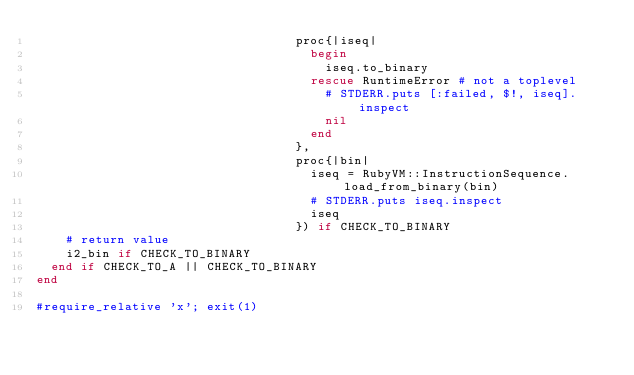<code> <loc_0><loc_0><loc_500><loc_500><_Ruby_>                                   proc{|iseq|
                                     begin
                                       iseq.to_binary
                                     rescue RuntimeError # not a toplevel
                                       # STDERR.puts [:failed, $!, iseq].inspect
                                       nil
                                     end
                                   },
                                   proc{|bin|
                                     iseq = RubyVM::InstructionSequence.load_from_binary(bin)
                                     # STDERR.puts iseq.inspect
                                     iseq
                                   }) if CHECK_TO_BINARY
    # return value
    i2_bin if CHECK_TO_BINARY
  end if CHECK_TO_A || CHECK_TO_BINARY
end

#require_relative 'x'; exit(1)
</code> 